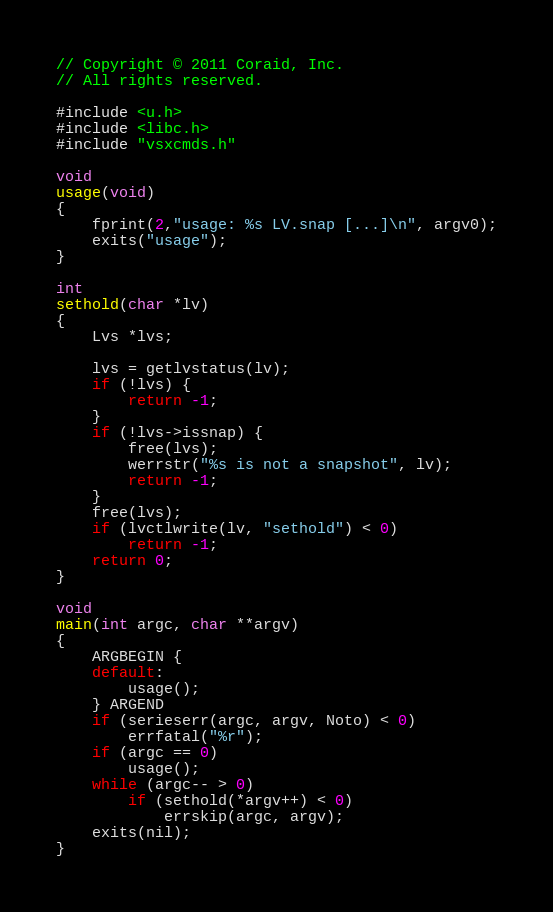<code> <loc_0><loc_0><loc_500><loc_500><_C_>// Copyright © 2011 Coraid, Inc.
// All rights reserved.

#include <u.h>
#include <libc.h>
#include "vsxcmds.h"

void
usage(void)
{
	fprint(2,"usage: %s LV.snap [...]\n", argv0);
	exits("usage");
}

int
sethold(char *lv)
{
	Lvs *lvs;

	lvs = getlvstatus(lv);
	if (!lvs) {
		return -1;
	}
	if (!lvs->issnap) {
		free(lvs);
		werrstr("%s is not a snapshot", lv);
		return -1;
	}
	free(lvs);
	if (lvctlwrite(lv, "sethold") < 0)
		return -1;
	return 0;
}

void
main(int argc, char **argv)
{
	ARGBEGIN {
	default:
		usage();
	} ARGEND
	if (serieserr(argc, argv, Noto) < 0)
		errfatal("%r");
	if (argc == 0)
		usage();
	while (argc-- > 0)
		if (sethold(*argv++) < 0)
			errskip(argc, argv);
	exits(nil);
}
</code> 